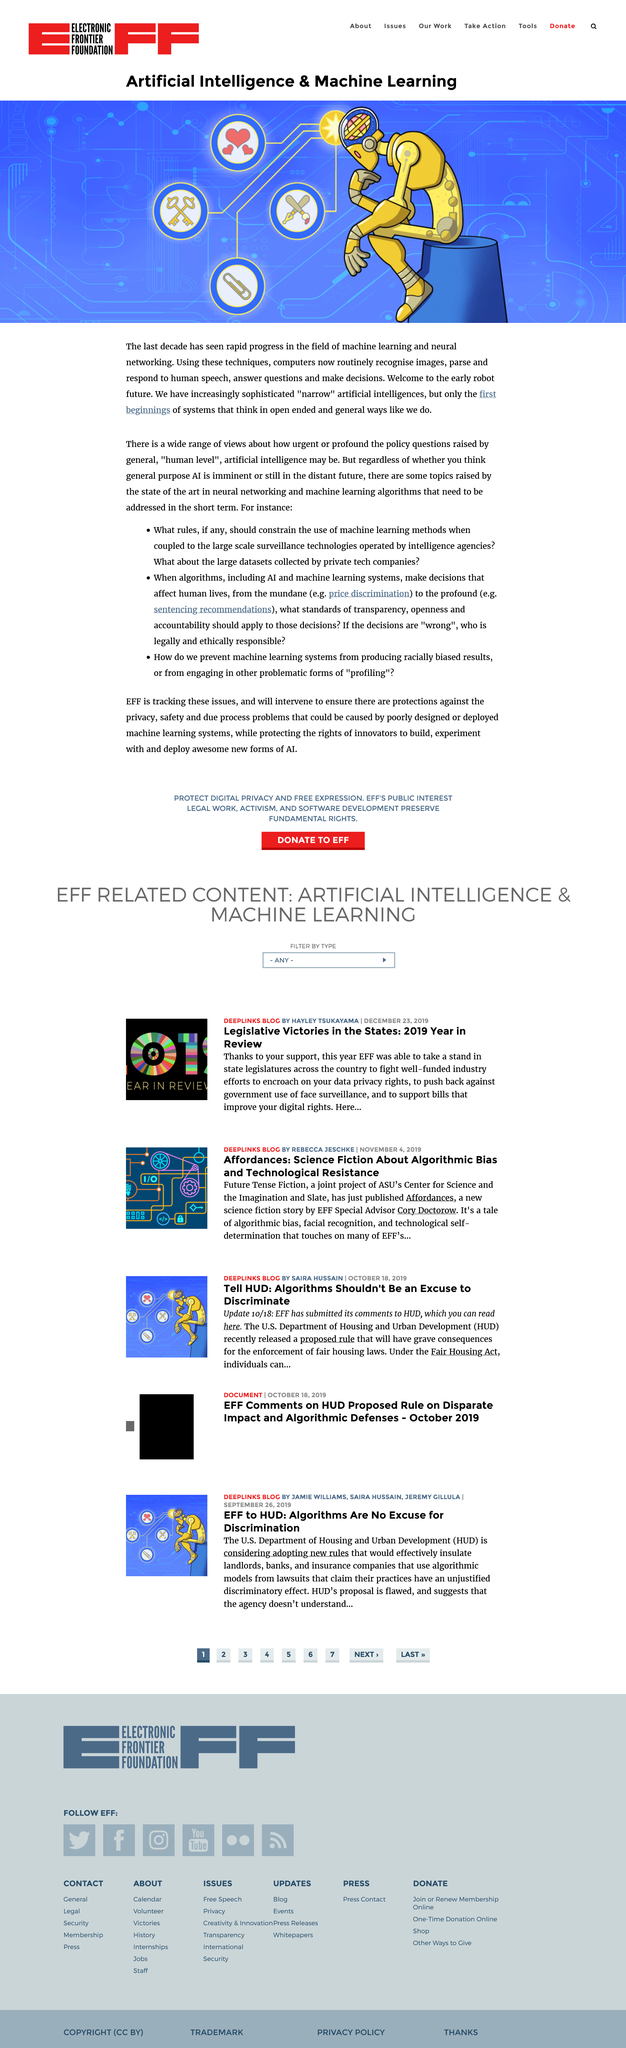Highlight a few significant elements in this photo. We have developed highly advanced and specialized artificial intelligences that are highly skilled in specific tasks, but lack the ability to understand and interact with the world in a more holistic and human-like way. In the last decade, the machine learning field has witnessed rapid progress, leading to significant advancements in the field. Artificial intelligences do not think in an open-ended and general way like humans do. 